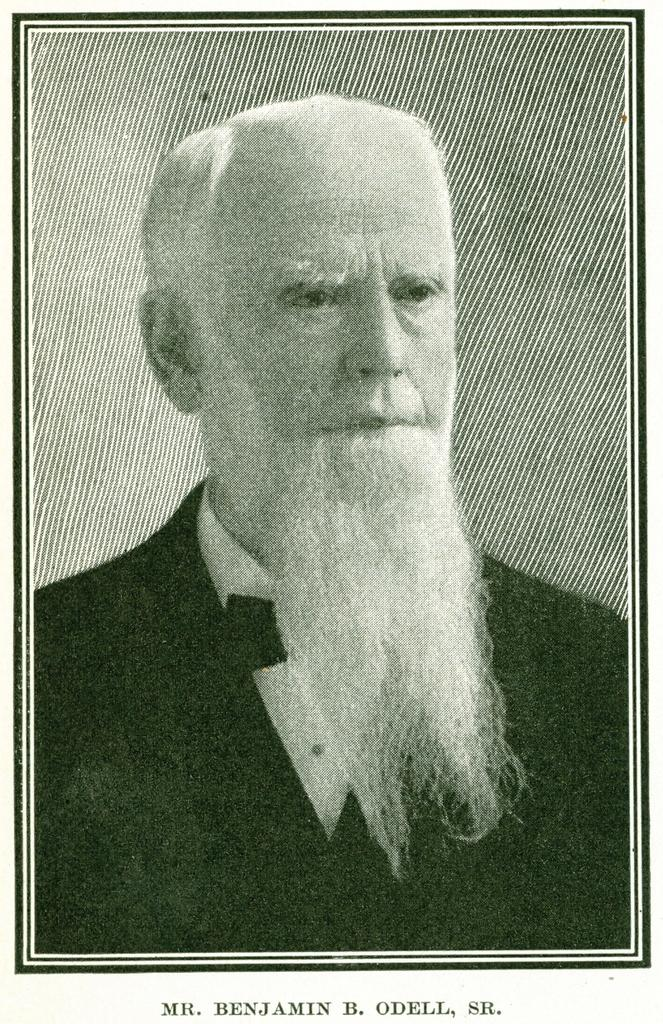What is the main subject of the image? There is a person in the image. Can you describe any additional details about the image? There is writing on the image. What type of toys can be seen in the middle of the image? There are no toys present in the image. 